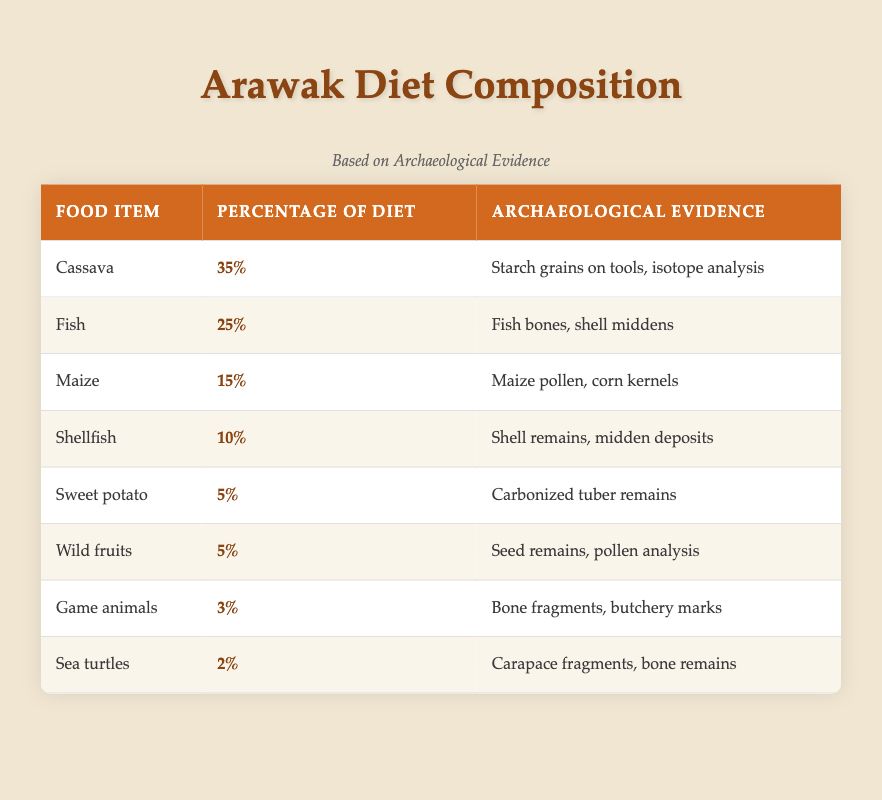What percentage of the Arawak diet is composed of cassava? The table shows that cassava makes up 35% of the Arawak diet according to the "Percentage of Diet" column.
Answer: 35% Which food item has the lowest percentage in the Arawak diet? Sea turtles have the lowest percentage at 2% in the "Percentage of Diet" column.
Answer: 2% Is fish a significant part of the Arawak diet compared to sweet potato? Yes, fish (25%) is significantly more than sweet potato (5%), indicating that fish is a more important food source.
Answer: Yes What is the total percentage of marine and aquatic food sources (fish, shellfish, and sea turtles) in the Arawak diet? To find the total percentage, we add the values: Fish (25%) + Shellfish (10%) + Sea turtles (2%) = 37%.
Answer: 37% What evidence is associated with maize consumption by the Arawak? The evidence associated with maize includes maize pollen and corn kernels, as listed in the "Archaeological Evidence" column.
Answer: Maize pollen, corn kernels Which food items are plant-based, and what percentage do they constitute in total? The plant-based items include cassava (35%), maize (15%), sweet potato (5%), and wild fruits (5%). Adding these gives 35% + 15% + 5% + 5% = 60%.
Answer: 60% 